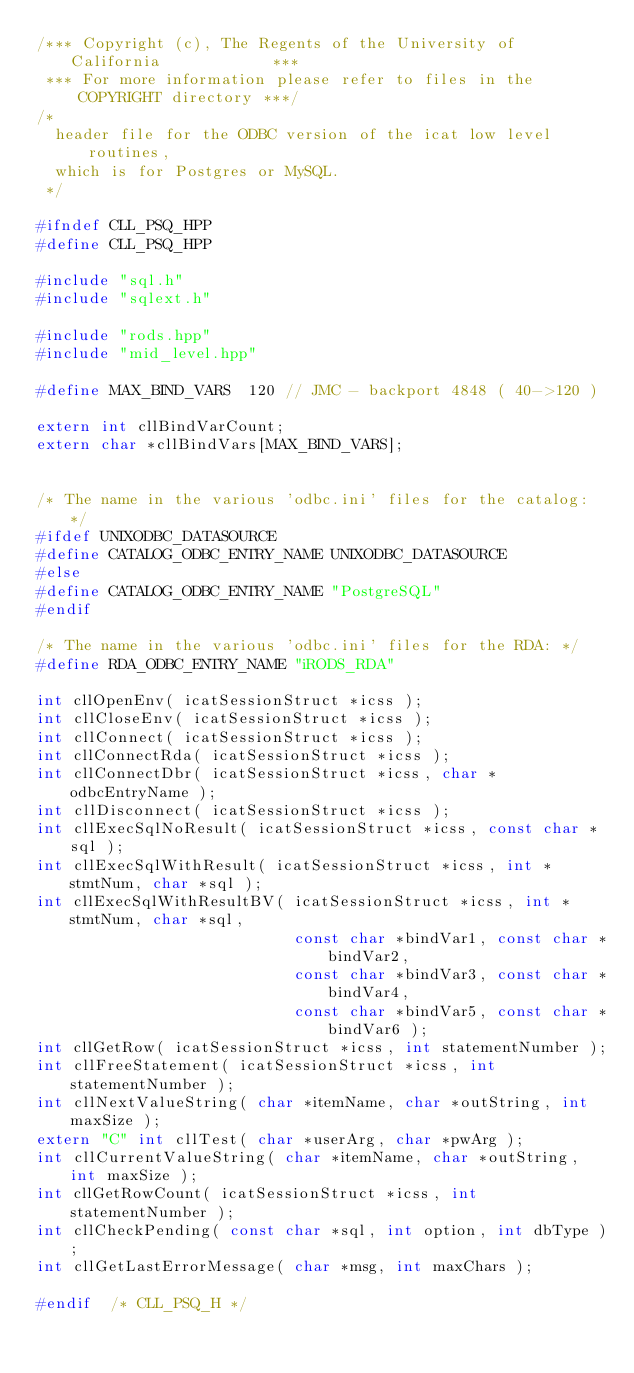Convert code to text. <code><loc_0><loc_0><loc_500><loc_500><_C++_>/*** Copyright (c), The Regents of the University of California            ***
 *** For more information please refer to files in the COPYRIGHT directory ***/
/*
  header file for the ODBC version of the icat low level routines,
  which is for Postgres or MySQL.
 */

#ifndef CLL_PSQ_HPP
#define CLL_PSQ_HPP

#include "sql.h"
#include "sqlext.h"

#include "rods.hpp"
#include "mid_level.hpp"

#define MAX_BIND_VARS  120 // JMC - backport 4848 ( 40->120 )

extern int cllBindVarCount;
extern char *cllBindVars[MAX_BIND_VARS];


/* The name in the various 'odbc.ini' files for the catalog: */
#ifdef UNIXODBC_DATASOURCE
#define CATALOG_ODBC_ENTRY_NAME UNIXODBC_DATASOURCE
#else
#define CATALOG_ODBC_ENTRY_NAME "PostgreSQL"
#endif

/* The name in the various 'odbc.ini' files for the RDA: */
#define RDA_ODBC_ENTRY_NAME "iRODS_RDA"

int cllOpenEnv( icatSessionStruct *icss );
int cllCloseEnv( icatSessionStruct *icss );
int cllConnect( icatSessionStruct *icss );
int cllConnectRda( icatSessionStruct *icss );
int cllConnectDbr( icatSessionStruct *icss, char *odbcEntryName );
int cllDisconnect( icatSessionStruct *icss );
int cllExecSqlNoResult( icatSessionStruct *icss, const char *sql );
int cllExecSqlWithResult( icatSessionStruct *icss, int *stmtNum, char *sql );
int cllExecSqlWithResultBV( icatSessionStruct *icss, int *stmtNum, char *sql,
                            const char *bindVar1, const char *bindVar2,
                            const char *bindVar3, const char *bindVar4,
                            const char *bindVar5, const char *bindVar6 );
int cllGetRow( icatSessionStruct *icss, int statementNumber );
int cllFreeStatement( icatSessionStruct *icss, int statementNumber );
int cllNextValueString( char *itemName, char *outString, int maxSize );
extern "C" int cllTest( char *userArg, char *pwArg );
int cllCurrentValueString( char *itemName, char *outString, int maxSize );
int cllGetRowCount( icatSessionStruct *icss, int statementNumber );
int cllCheckPending( const char *sql, int option, int dbType );
int cllGetLastErrorMessage( char *msg, int maxChars );

#endif	/* CLL_PSQ_H */
</code> 